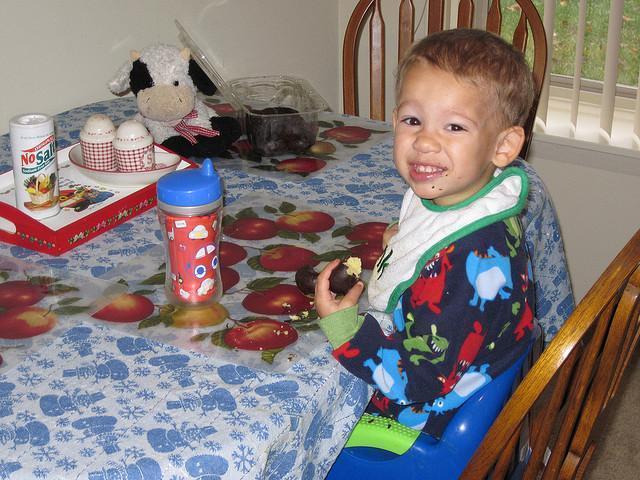How many chairs are in the photo?
Give a very brief answer. 2. 